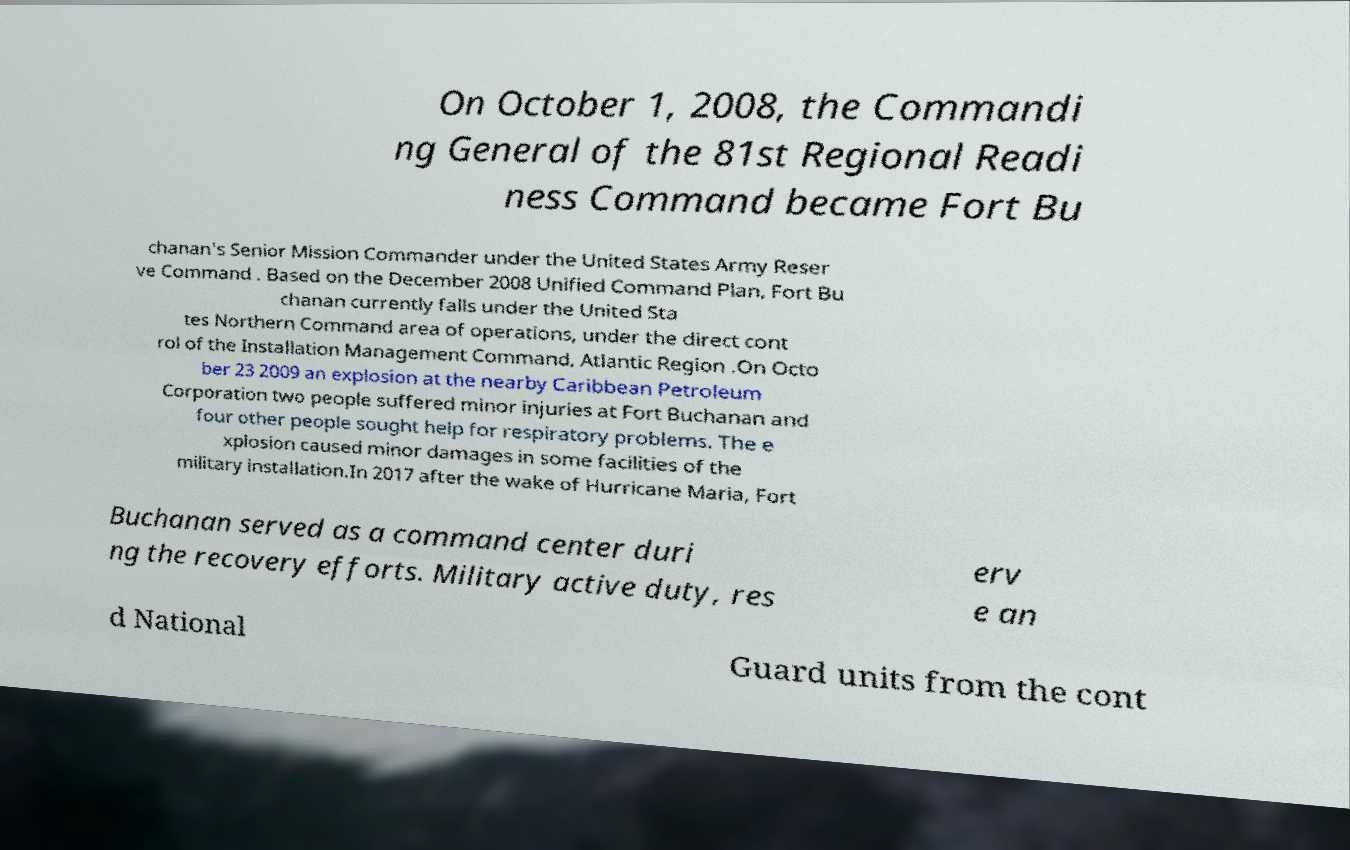Please read and relay the text visible in this image. What does it say? On October 1, 2008, the Commandi ng General of the 81st Regional Readi ness Command became Fort Bu chanan's Senior Mission Commander under the United States Army Reser ve Command . Based on the December 2008 Unified Command Plan, Fort Bu chanan currently falls under the United Sta tes Northern Command area of operations, under the direct cont rol of the Installation Management Command, Atlantic Region .On Octo ber 23 2009 an explosion at the nearby Caribbean Petroleum Corporation two people suffered minor injuries at Fort Buchanan and four other people sought help for respiratory problems. The e xplosion caused minor damages in some facilities of the military installation.In 2017 after the wake of Hurricane Maria, Fort Buchanan served as a command center duri ng the recovery efforts. Military active duty, res erv e an d National Guard units from the cont 